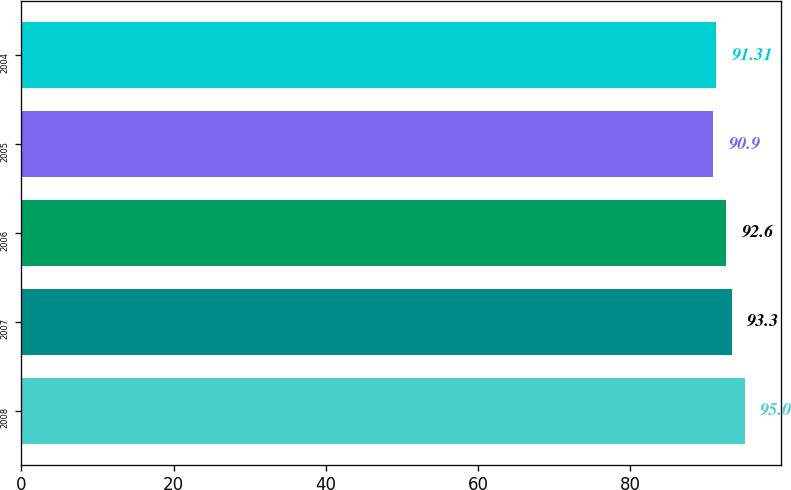Convert chart. <chart><loc_0><loc_0><loc_500><loc_500><bar_chart><fcel>2008<fcel>2007<fcel>2006<fcel>2005<fcel>2004<nl><fcel>95<fcel>93.3<fcel>92.6<fcel>90.9<fcel>91.31<nl></chart> 